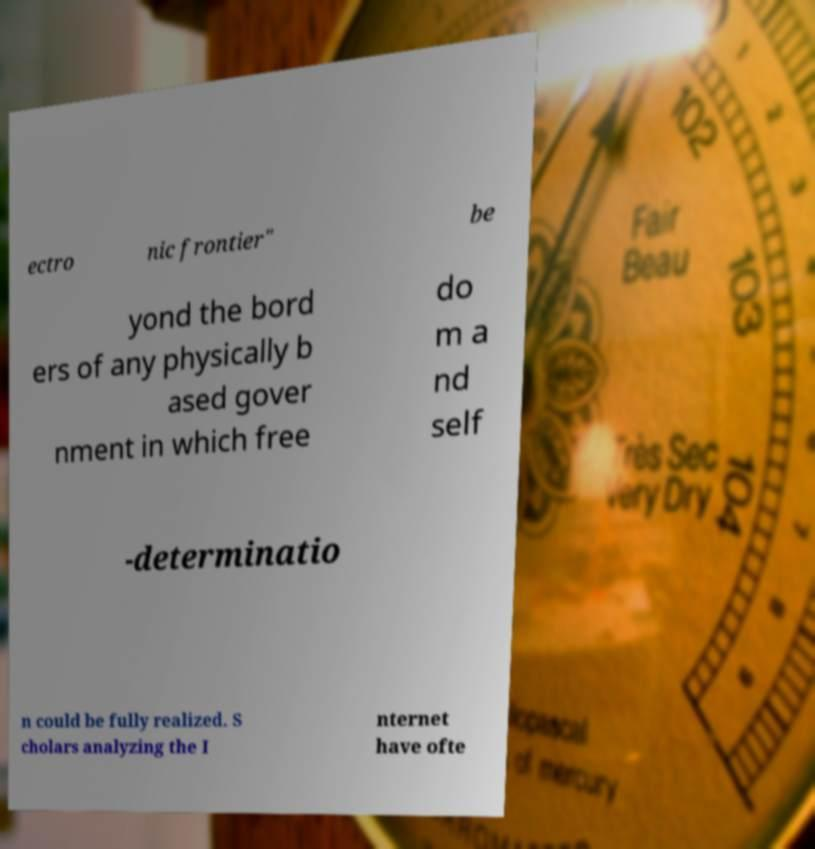What messages or text are displayed in this image? I need them in a readable, typed format. ectro nic frontier" be yond the bord ers of any physically b ased gover nment in which free do m a nd self -determinatio n could be fully realized. S cholars analyzing the I nternet have ofte 